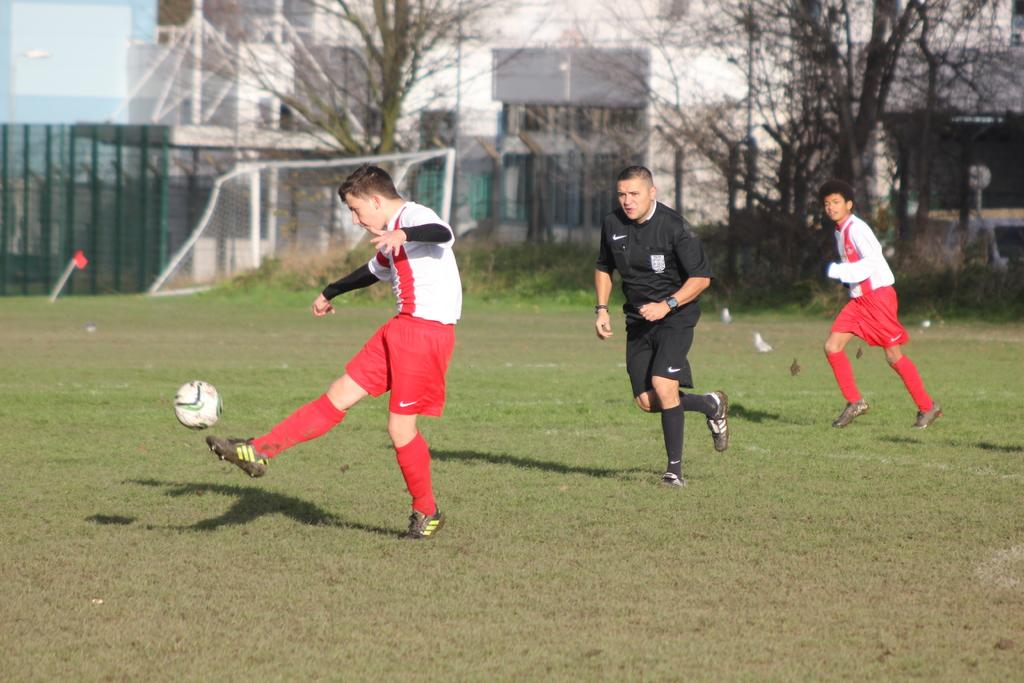What is happening in the center of the image? There are three players in the center of the image. Where is the ball located in the image? The ball is on the left side of the image. What can be seen in the background of the image? There is a building, trees, grass, and a net in the background of the image. What type of wool is being spun by the players in the image? There is no wool or spinning activity present in the image; it features three players and a ball. What observation can be made about the players' skate skills in the image? There is no skating activity present in the image, so it is not possible to make any observations about the players' skate skills. 